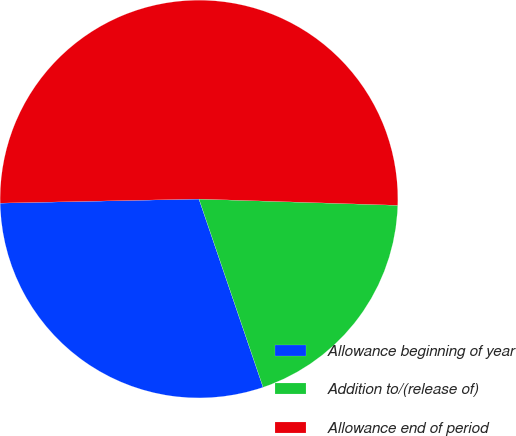Convert chart. <chart><loc_0><loc_0><loc_500><loc_500><pie_chart><fcel>Allowance beginning of year<fcel>Addition to/(release of)<fcel>Allowance end of period<nl><fcel>29.9%<fcel>19.27%<fcel>50.83%<nl></chart> 